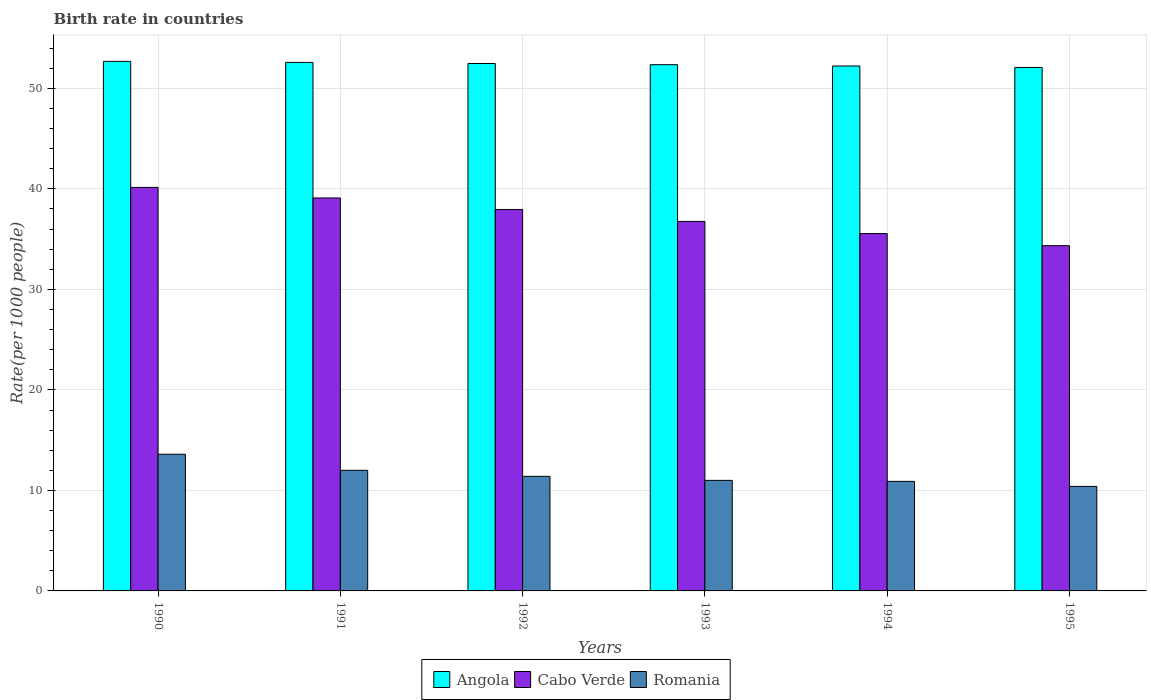What is the label of the 5th group of bars from the left?
Make the answer very short. 1994. What is the birth rate in Romania in 1992?
Ensure brevity in your answer.  11.4. Across all years, what is the maximum birth rate in Angola?
Provide a short and direct response. 52.69. Across all years, what is the minimum birth rate in Angola?
Make the answer very short. 52.08. In which year was the birth rate in Angola maximum?
Make the answer very short. 1990. In which year was the birth rate in Cabo Verde minimum?
Your answer should be very brief. 1995. What is the total birth rate in Romania in the graph?
Your answer should be compact. 69.3. What is the difference between the birth rate in Angola in 1991 and that in 1994?
Give a very brief answer. 0.36. What is the difference between the birth rate in Angola in 1991 and the birth rate in Cabo Verde in 1995?
Provide a succinct answer. 18.24. What is the average birth rate in Angola per year?
Provide a succinct answer. 52.4. In the year 1993, what is the difference between the birth rate in Romania and birth rate in Angola?
Provide a succinct answer. -41.36. In how many years, is the birth rate in Angola greater than 42?
Your answer should be compact. 6. What is the ratio of the birth rate in Romania in 1990 to that in 1994?
Your answer should be compact. 1.25. What is the difference between the highest and the second highest birth rate in Romania?
Provide a short and direct response. 1.6. What is the difference between the highest and the lowest birth rate in Angola?
Provide a succinct answer. 0.61. What does the 3rd bar from the left in 1990 represents?
Give a very brief answer. Romania. What does the 2nd bar from the right in 1990 represents?
Offer a very short reply. Cabo Verde. Are all the bars in the graph horizontal?
Make the answer very short. No. What is the difference between two consecutive major ticks on the Y-axis?
Your answer should be compact. 10. Does the graph contain grids?
Ensure brevity in your answer.  Yes. What is the title of the graph?
Give a very brief answer. Birth rate in countries. Does "Turks and Caicos Islands" appear as one of the legend labels in the graph?
Your response must be concise. No. What is the label or title of the X-axis?
Keep it short and to the point. Years. What is the label or title of the Y-axis?
Ensure brevity in your answer.  Rate(per 1000 people). What is the Rate(per 1000 people) of Angola in 1990?
Offer a terse response. 52.69. What is the Rate(per 1000 people) in Cabo Verde in 1990?
Offer a terse response. 40.15. What is the Rate(per 1000 people) in Angola in 1991?
Provide a short and direct response. 52.59. What is the Rate(per 1000 people) in Cabo Verde in 1991?
Your answer should be very brief. 39.1. What is the Rate(per 1000 people) of Angola in 1992?
Provide a short and direct response. 52.48. What is the Rate(per 1000 people) of Cabo Verde in 1992?
Give a very brief answer. 37.95. What is the Rate(per 1000 people) in Romania in 1992?
Offer a terse response. 11.4. What is the Rate(per 1000 people) in Angola in 1993?
Your answer should be very brief. 52.36. What is the Rate(per 1000 people) in Cabo Verde in 1993?
Your answer should be compact. 36.76. What is the Rate(per 1000 people) in Romania in 1993?
Ensure brevity in your answer.  11. What is the Rate(per 1000 people) of Angola in 1994?
Your answer should be very brief. 52.23. What is the Rate(per 1000 people) in Cabo Verde in 1994?
Provide a succinct answer. 35.56. What is the Rate(per 1000 people) in Angola in 1995?
Provide a succinct answer. 52.08. What is the Rate(per 1000 people) in Cabo Verde in 1995?
Give a very brief answer. 34.35. Across all years, what is the maximum Rate(per 1000 people) in Angola?
Keep it short and to the point. 52.69. Across all years, what is the maximum Rate(per 1000 people) of Cabo Verde?
Your answer should be very brief. 40.15. Across all years, what is the maximum Rate(per 1000 people) in Romania?
Keep it short and to the point. 13.6. Across all years, what is the minimum Rate(per 1000 people) of Angola?
Make the answer very short. 52.08. Across all years, what is the minimum Rate(per 1000 people) in Cabo Verde?
Your answer should be very brief. 34.35. Across all years, what is the minimum Rate(per 1000 people) of Romania?
Ensure brevity in your answer.  10.4. What is the total Rate(per 1000 people) in Angola in the graph?
Offer a terse response. 314.41. What is the total Rate(per 1000 people) in Cabo Verde in the graph?
Keep it short and to the point. 223.86. What is the total Rate(per 1000 people) in Romania in the graph?
Give a very brief answer. 69.3. What is the difference between the Rate(per 1000 people) of Angola in 1990 and that in 1991?
Give a very brief answer. 0.1. What is the difference between the Rate(per 1000 people) in Angola in 1990 and that in 1992?
Ensure brevity in your answer.  0.21. What is the difference between the Rate(per 1000 people) of Cabo Verde in 1990 and that in 1992?
Your answer should be very brief. 2.19. What is the difference between the Rate(per 1000 people) of Angola in 1990 and that in 1993?
Your response must be concise. 0.33. What is the difference between the Rate(per 1000 people) of Cabo Verde in 1990 and that in 1993?
Give a very brief answer. 3.39. What is the difference between the Rate(per 1000 people) of Angola in 1990 and that in 1994?
Offer a terse response. 0.46. What is the difference between the Rate(per 1000 people) of Cabo Verde in 1990 and that in 1994?
Keep it short and to the point. 4.59. What is the difference between the Rate(per 1000 people) of Romania in 1990 and that in 1994?
Your response must be concise. 2.7. What is the difference between the Rate(per 1000 people) of Angola in 1990 and that in 1995?
Keep it short and to the point. 0.61. What is the difference between the Rate(per 1000 people) in Cabo Verde in 1990 and that in 1995?
Your answer should be very brief. 5.8. What is the difference between the Rate(per 1000 people) of Romania in 1990 and that in 1995?
Your answer should be compact. 3.2. What is the difference between the Rate(per 1000 people) of Angola in 1991 and that in 1992?
Ensure brevity in your answer.  0.11. What is the difference between the Rate(per 1000 people) in Cabo Verde in 1991 and that in 1992?
Provide a succinct answer. 1.15. What is the difference between the Rate(per 1000 people) in Angola in 1991 and that in 1993?
Offer a terse response. 0.23. What is the difference between the Rate(per 1000 people) of Cabo Verde in 1991 and that in 1993?
Your answer should be compact. 2.34. What is the difference between the Rate(per 1000 people) in Romania in 1991 and that in 1993?
Keep it short and to the point. 1. What is the difference between the Rate(per 1000 people) in Angola in 1991 and that in 1994?
Your answer should be very brief. 0.36. What is the difference between the Rate(per 1000 people) of Cabo Verde in 1991 and that in 1994?
Offer a terse response. 3.54. What is the difference between the Rate(per 1000 people) of Angola in 1991 and that in 1995?
Make the answer very short. 0.5. What is the difference between the Rate(per 1000 people) in Cabo Verde in 1991 and that in 1995?
Your answer should be compact. 4.75. What is the difference between the Rate(per 1000 people) in Romania in 1991 and that in 1995?
Provide a succinct answer. 1.6. What is the difference between the Rate(per 1000 people) of Angola in 1992 and that in 1993?
Ensure brevity in your answer.  0.12. What is the difference between the Rate(per 1000 people) in Cabo Verde in 1992 and that in 1993?
Keep it short and to the point. 1.19. What is the difference between the Rate(per 1000 people) of Angola in 1992 and that in 1994?
Your answer should be very brief. 0.25. What is the difference between the Rate(per 1000 people) of Cabo Verde in 1992 and that in 1994?
Your answer should be very brief. 2.4. What is the difference between the Rate(per 1000 people) in Angola in 1992 and that in 1995?
Make the answer very short. 0.39. What is the difference between the Rate(per 1000 people) in Cabo Verde in 1992 and that in 1995?
Provide a succinct answer. 3.6. What is the difference between the Rate(per 1000 people) in Romania in 1992 and that in 1995?
Your answer should be compact. 1. What is the difference between the Rate(per 1000 people) in Angola in 1993 and that in 1994?
Your answer should be compact. 0.13. What is the difference between the Rate(per 1000 people) of Cabo Verde in 1993 and that in 1994?
Make the answer very short. 1.21. What is the difference between the Rate(per 1000 people) in Romania in 1993 and that in 1994?
Ensure brevity in your answer.  0.1. What is the difference between the Rate(per 1000 people) of Angola in 1993 and that in 1995?
Your response must be concise. 0.28. What is the difference between the Rate(per 1000 people) in Cabo Verde in 1993 and that in 1995?
Your answer should be compact. 2.41. What is the difference between the Rate(per 1000 people) in Angola in 1994 and that in 1995?
Your response must be concise. 0.15. What is the difference between the Rate(per 1000 people) of Cabo Verde in 1994 and that in 1995?
Your response must be concise. 1.21. What is the difference between the Rate(per 1000 people) in Romania in 1994 and that in 1995?
Provide a short and direct response. 0.5. What is the difference between the Rate(per 1000 people) of Angola in 1990 and the Rate(per 1000 people) of Cabo Verde in 1991?
Keep it short and to the point. 13.59. What is the difference between the Rate(per 1000 people) in Angola in 1990 and the Rate(per 1000 people) in Romania in 1991?
Provide a succinct answer. 40.69. What is the difference between the Rate(per 1000 people) of Cabo Verde in 1990 and the Rate(per 1000 people) of Romania in 1991?
Make the answer very short. 28.15. What is the difference between the Rate(per 1000 people) in Angola in 1990 and the Rate(per 1000 people) in Cabo Verde in 1992?
Provide a succinct answer. 14.74. What is the difference between the Rate(per 1000 people) in Angola in 1990 and the Rate(per 1000 people) in Romania in 1992?
Your answer should be compact. 41.29. What is the difference between the Rate(per 1000 people) in Cabo Verde in 1990 and the Rate(per 1000 people) in Romania in 1992?
Your response must be concise. 28.75. What is the difference between the Rate(per 1000 people) in Angola in 1990 and the Rate(per 1000 people) in Cabo Verde in 1993?
Give a very brief answer. 15.93. What is the difference between the Rate(per 1000 people) of Angola in 1990 and the Rate(per 1000 people) of Romania in 1993?
Offer a very short reply. 41.69. What is the difference between the Rate(per 1000 people) in Cabo Verde in 1990 and the Rate(per 1000 people) in Romania in 1993?
Your response must be concise. 29.15. What is the difference between the Rate(per 1000 people) in Angola in 1990 and the Rate(per 1000 people) in Cabo Verde in 1994?
Your answer should be compact. 17.13. What is the difference between the Rate(per 1000 people) of Angola in 1990 and the Rate(per 1000 people) of Romania in 1994?
Your answer should be compact. 41.79. What is the difference between the Rate(per 1000 people) in Cabo Verde in 1990 and the Rate(per 1000 people) in Romania in 1994?
Offer a very short reply. 29.25. What is the difference between the Rate(per 1000 people) of Angola in 1990 and the Rate(per 1000 people) of Cabo Verde in 1995?
Keep it short and to the point. 18.34. What is the difference between the Rate(per 1000 people) in Angola in 1990 and the Rate(per 1000 people) in Romania in 1995?
Make the answer very short. 42.29. What is the difference between the Rate(per 1000 people) in Cabo Verde in 1990 and the Rate(per 1000 people) in Romania in 1995?
Your response must be concise. 29.75. What is the difference between the Rate(per 1000 people) in Angola in 1991 and the Rate(per 1000 people) in Cabo Verde in 1992?
Give a very brief answer. 14.63. What is the difference between the Rate(per 1000 people) in Angola in 1991 and the Rate(per 1000 people) in Romania in 1992?
Give a very brief answer. 41.19. What is the difference between the Rate(per 1000 people) in Cabo Verde in 1991 and the Rate(per 1000 people) in Romania in 1992?
Offer a very short reply. 27.7. What is the difference between the Rate(per 1000 people) of Angola in 1991 and the Rate(per 1000 people) of Cabo Verde in 1993?
Provide a succinct answer. 15.82. What is the difference between the Rate(per 1000 people) in Angola in 1991 and the Rate(per 1000 people) in Romania in 1993?
Your answer should be compact. 41.59. What is the difference between the Rate(per 1000 people) in Cabo Verde in 1991 and the Rate(per 1000 people) in Romania in 1993?
Offer a very short reply. 28.1. What is the difference between the Rate(per 1000 people) in Angola in 1991 and the Rate(per 1000 people) in Cabo Verde in 1994?
Offer a very short reply. 17.03. What is the difference between the Rate(per 1000 people) in Angola in 1991 and the Rate(per 1000 people) in Romania in 1994?
Make the answer very short. 41.69. What is the difference between the Rate(per 1000 people) of Cabo Verde in 1991 and the Rate(per 1000 people) of Romania in 1994?
Make the answer very short. 28.2. What is the difference between the Rate(per 1000 people) of Angola in 1991 and the Rate(per 1000 people) of Cabo Verde in 1995?
Give a very brief answer. 18.24. What is the difference between the Rate(per 1000 people) of Angola in 1991 and the Rate(per 1000 people) of Romania in 1995?
Give a very brief answer. 42.19. What is the difference between the Rate(per 1000 people) in Cabo Verde in 1991 and the Rate(per 1000 people) in Romania in 1995?
Keep it short and to the point. 28.7. What is the difference between the Rate(per 1000 people) in Angola in 1992 and the Rate(per 1000 people) in Cabo Verde in 1993?
Provide a short and direct response. 15.71. What is the difference between the Rate(per 1000 people) of Angola in 1992 and the Rate(per 1000 people) of Romania in 1993?
Keep it short and to the point. 41.48. What is the difference between the Rate(per 1000 people) of Cabo Verde in 1992 and the Rate(per 1000 people) of Romania in 1993?
Your answer should be very brief. 26.95. What is the difference between the Rate(per 1000 people) in Angola in 1992 and the Rate(per 1000 people) in Cabo Verde in 1994?
Provide a succinct answer. 16.92. What is the difference between the Rate(per 1000 people) of Angola in 1992 and the Rate(per 1000 people) of Romania in 1994?
Offer a terse response. 41.58. What is the difference between the Rate(per 1000 people) of Cabo Verde in 1992 and the Rate(per 1000 people) of Romania in 1994?
Offer a very short reply. 27.05. What is the difference between the Rate(per 1000 people) in Angola in 1992 and the Rate(per 1000 people) in Cabo Verde in 1995?
Your answer should be compact. 18.13. What is the difference between the Rate(per 1000 people) of Angola in 1992 and the Rate(per 1000 people) of Romania in 1995?
Provide a short and direct response. 42.08. What is the difference between the Rate(per 1000 people) in Cabo Verde in 1992 and the Rate(per 1000 people) in Romania in 1995?
Your response must be concise. 27.55. What is the difference between the Rate(per 1000 people) of Angola in 1993 and the Rate(per 1000 people) of Cabo Verde in 1994?
Make the answer very short. 16.8. What is the difference between the Rate(per 1000 people) in Angola in 1993 and the Rate(per 1000 people) in Romania in 1994?
Provide a succinct answer. 41.46. What is the difference between the Rate(per 1000 people) in Cabo Verde in 1993 and the Rate(per 1000 people) in Romania in 1994?
Keep it short and to the point. 25.86. What is the difference between the Rate(per 1000 people) of Angola in 1993 and the Rate(per 1000 people) of Cabo Verde in 1995?
Make the answer very short. 18.01. What is the difference between the Rate(per 1000 people) in Angola in 1993 and the Rate(per 1000 people) in Romania in 1995?
Offer a terse response. 41.96. What is the difference between the Rate(per 1000 people) of Cabo Verde in 1993 and the Rate(per 1000 people) of Romania in 1995?
Ensure brevity in your answer.  26.36. What is the difference between the Rate(per 1000 people) in Angola in 1994 and the Rate(per 1000 people) in Cabo Verde in 1995?
Provide a short and direct response. 17.88. What is the difference between the Rate(per 1000 people) in Angola in 1994 and the Rate(per 1000 people) in Romania in 1995?
Your answer should be compact. 41.83. What is the difference between the Rate(per 1000 people) of Cabo Verde in 1994 and the Rate(per 1000 people) of Romania in 1995?
Your answer should be very brief. 25.16. What is the average Rate(per 1000 people) in Angola per year?
Your answer should be compact. 52.4. What is the average Rate(per 1000 people) of Cabo Verde per year?
Offer a very short reply. 37.31. What is the average Rate(per 1000 people) in Romania per year?
Ensure brevity in your answer.  11.55. In the year 1990, what is the difference between the Rate(per 1000 people) in Angola and Rate(per 1000 people) in Cabo Verde?
Your response must be concise. 12.54. In the year 1990, what is the difference between the Rate(per 1000 people) in Angola and Rate(per 1000 people) in Romania?
Your answer should be compact. 39.09. In the year 1990, what is the difference between the Rate(per 1000 people) of Cabo Verde and Rate(per 1000 people) of Romania?
Provide a succinct answer. 26.55. In the year 1991, what is the difference between the Rate(per 1000 people) in Angola and Rate(per 1000 people) in Cabo Verde?
Offer a terse response. 13.49. In the year 1991, what is the difference between the Rate(per 1000 people) in Angola and Rate(per 1000 people) in Romania?
Offer a terse response. 40.59. In the year 1991, what is the difference between the Rate(per 1000 people) in Cabo Verde and Rate(per 1000 people) in Romania?
Your answer should be very brief. 27.1. In the year 1992, what is the difference between the Rate(per 1000 people) of Angola and Rate(per 1000 people) of Cabo Verde?
Offer a very short reply. 14.52. In the year 1992, what is the difference between the Rate(per 1000 people) in Angola and Rate(per 1000 people) in Romania?
Provide a succinct answer. 41.08. In the year 1992, what is the difference between the Rate(per 1000 people) in Cabo Verde and Rate(per 1000 people) in Romania?
Your response must be concise. 26.55. In the year 1993, what is the difference between the Rate(per 1000 people) of Angola and Rate(per 1000 people) of Cabo Verde?
Offer a very short reply. 15.6. In the year 1993, what is the difference between the Rate(per 1000 people) in Angola and Rate(per 1000 people) in Romania?
Make the answer very short. 41.36. In the year 1993, what is the difference between the Rate(per 1000 people) of Cabo Verde and Rate(per 1000 people) of Romania?
Your answer should be compact. 25.76. In the year 1994, what is the difference between the Rate(per 1000 people) in Angola and Rate(per 1000 people) in Cabo Verde?
Offer a terse response. 16.67. In the year 1994, what is the difference between the Rate(per 1000 people) of Angola and Rate(per 1000 people) of Romania?
Your answer should be very brief. 41.33. In the year 1994, what is the difference between the Rate(per 1000 people) of Cabo Verde and Rate(per 1000 people) of Romania?
Ensure brevity in your answer.  24.66. In the year 1995, what is the difference between the Rate(per 1000 people) in Angola and Rate(per 1000 people) in Cabo Verde?
Provide a short and direct response. 17.73. In the year 1995, what is the difference between the Rate(per 1000 people) in Angola and Rate(per 1000 people) in Romania?
Make the answer very short. 41.68. In the year 1995, what is the difference between the Rate(per 1000 people) in Cabo Verde and Rate(per 1000 people) in Romania?
Make the answer very short. 23.95. What is the ratio of the Rate(per 1000 people) of Angola in 1990 to that in 1991?
Provide a succinct answer. 1. What is the ratio of the Rate(per 1000 people) of Cabo Verde in 1990 to that in 1991?
Your response must be concise. 1.03. What is the ratio of the Rate(per 1000 people) of Romania in 1990 to that in 1991?
Give a very brief answer. 1.13. What is the ratio of the Rate(per 1000 people) in Angola in 1990 to that in 1992?
Provide a succinct answer. 1. What is the ratio of the Rate(per 1000 people) in Cabo Verde in 1990 to that in 1992?
Keep it short and to the point. 1.06. What is the ratio of the Rate(per 1000 people) of Romania in 1990 to that in 1992?
Provide a short and direct response. 1.19. What is the ratio of the Rate(per 1000 people) of Angola in 1990 to that in 1993?
Provide a short and direct response. 1.01. What is the ratio of the Rate(per 1000 people) of Cabo Verde in 1990 to that in 1993?
Your answer should be compact. 1.09. What is the ratio of the Rate(per 1000 people) in Romania in 1990 to that in 1993?
Make the answer very short. 1.24. What is the ratio of the Rate(per 1000 people) of Angola in 1990 to that in 1994?
Make the answer very short. 1.01. What is the ratio of the Rate(per 1000 people) of Cabo Verde in 1990 to that in 1994?
Make the answer very short. 1.13. What is the ratio of the Rate(per 1000 people) of Romania in 1990 to that in 1994?
Provide a short and direct response. 1.25. What is the ratio of the Rate(per 1000 people) in Angola in 1990 to that in 1995?
Give a very brief answer. 1.01. What is the ratio of the Rate(per 1000 people) of Cabo Verde in 1990 to that in 1995?
Make the answer very short. 1.17. What is the ratio of the Rate(per 1000 people) of Romania in 1990 to that in 1995?
Your answer should be very brief. 1.31. What is the ratio of the Rate(per 1000 people) of Cabo Verde in 1991 to that in 1992?
Your response must be concise. 1.03. What is the ratio of the Rate(per 1000 people) in Romania in 1991 to that in 1992?
Your response must be concise. 1.05. What is the ratio of the Rate(per 1000 people) of Cabo Verde in 1991 to that in 1993?
Keep it short and to the point. 1.06. What is the ratio of the Rate(per 1000 people) in Romania in 1991 to that in 1993?
Keep it short and to the point. 1.09. What is the ratio of the Rate(per 1000 people) in Angola in 1991 to that in 1994?
Provide a succinct answer. 1.01. What is the ratio of the Rate(per 1000 people) of Cabo Verde in 1991 to that in 1994?
Keep it short and to the point. 1.1. What is the ratio of the Rate(per 1000 people) of Romania in 1991 to that in 1994?
Offer a terse response. 1.1. What is the ratio of the Rate(per 1000 people) of Angola in 1991 to that in 1995?
Offer a very short reply. 1.01. What is the ratio of the Rate(per 1000 people) in Cabo Verde in 1991 to that in 1995?
Your answer should be compact. 1.14. What is the ratio of the Rate(per 1000 people) in Romania in 1991 to that in 1995?
Your answer should be compact. 1.15. What is the ratio of the Rate(per 1000 people) in Angola in 1992 to that in 1993?
Provide a short and direct response. 1. What is the ratio of the Rate(per 1000 people) in Cabo Verde in 1992 to that in 1993?
Your answer should be very brief. 1.03. What is the ratio of the Rate(per 1000 people) in Romania in 1992 to that in 1993?
Offer a very short reply. 1.04. What is the ratio of the Rate(per 1000 people) of Cabo Verde in 1992 to that in 1994?
Your answer should be very brief. 1.07. What is the ratio of the Rate(per 1000 people) of Romania in 1992 to that in 1994?
Your response must be concise. 1.05. What is the ratio of the Rate(per 1000 people) in Angola in 1992 to that in 1995?
Keep it short and to the point. 1.01. What is the ratio of the Rate(per 1000 people) in Cabo Verde in 1992 to that in 1995?
Provide a short and direct response. 1.1. What is the ratio of the Rate(per 1000 people) of Romania in 1992 to that in 1995?
Your answer should be compact. 1.1. What is the ratio of the Rate(per 1000 people) in Angola in 1993 to that in 1994?
Ensure brevity in your answer.  1. What is the ratio of the Rate(per 1000 people) of Cabo Verde in 1993 to that in 1994?
Make the answer very short. 1.03. What is the ratio of the Rate(per 1000 people) in Romania in 1993 to that in 1994?
Give a very brief answer. 1.01. What is the ratio of the Rate(per 1000 people) in Cabo Verde in 1993 to that in 1995?
Your response must be concise. 1.07. What is the ratio of the Rate(per 1000 people) of Romania in 1993 to that in 1995?
Give a very brief answer. 1.06. What is the ratio of the Rate(per 1000 people) in Cabo Verde in 1994 to that in 1995?
Offer a very short reply. 1.04. What is the ratio of the Rate(per 1000 people) of Romania in 1994 to that in 1995?
Your answer should be compact. 1.05. What is the difference between the highest and the second highest Rate(per 1000 people) of Angola?
Your answer should be compact. 0.1. What is the difference between the highest and the second highest Rate(per 1000 people) of Cabo Verde?
Ensure brevity in your answer.  1.05. What is the difference between the highest and the lowest Rate(per 1000 people) of Angola?
Provide a succinct answer. 0.61. What is the difference between the highest and the lowest Rate(per 1000 people) in Cabo Verde?
Keep it short and to the point. 5.8. What is the difference between the highest and the lowest Rate(per 1000 people) of Romania?
Keep it short and to the point. 3.2. 